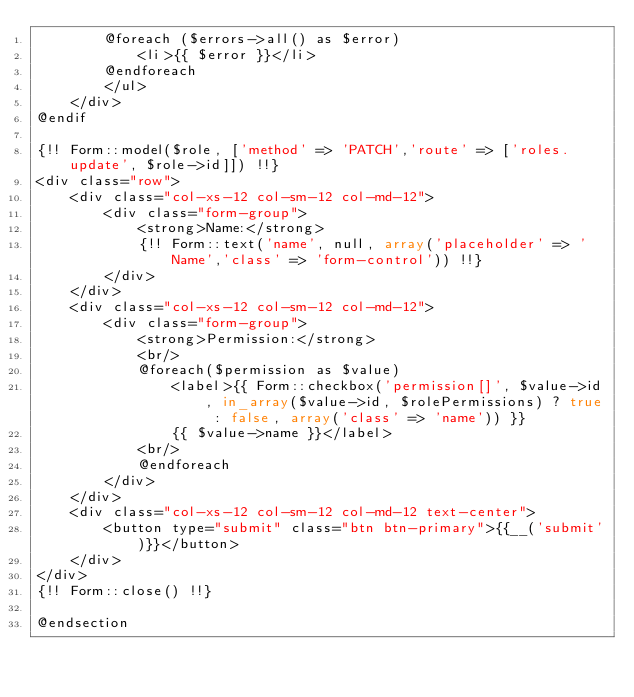Convert code to text. <code><loc_0><loc_0><loc_500><loc_500><_PHP_>        @foreach ($errors->all() as $error)
            <li>{{ $error }}</li>
        @endforeach
        </ul>
    </div>
@endif

{!! Form::model($role, ['method' => 'PATCH','route' => ['roles.update', $role->id]]) !!}
<div class="row">
    <div class="col-xs-12 col-sm-12 col-md-12">
        <div class="form-group">
            <strong>Name:</strong>
            {!! Form::text('name', null, array('placeholder' => 'Name','class' => 'form-control')) !!}
        </div>
    </div>
    <div class="col-xs-12 col-sm-12 col-md-12">
        <div class="form-group">
            <strong>Permission:</strong>
            <br/>
            @foreach($permission as $value)
                <label>{{ Form::checkbox('permission[]', $value->id, in_array($value->id, $rolePermissions) ? true : false, array('class' => 'name')) }}
                {{ $value->name }}</label>
            <br/>
            @endforeach
        </div>
    </div>
    <div class="col-xs-12 col-sm-12 col-md-12 text-center">
        <button type="submit" class="btn btn-primary">{{__('submit')}}</button>
    </div>
</div>
{!! Form::close() !!}

@endsection</code> 